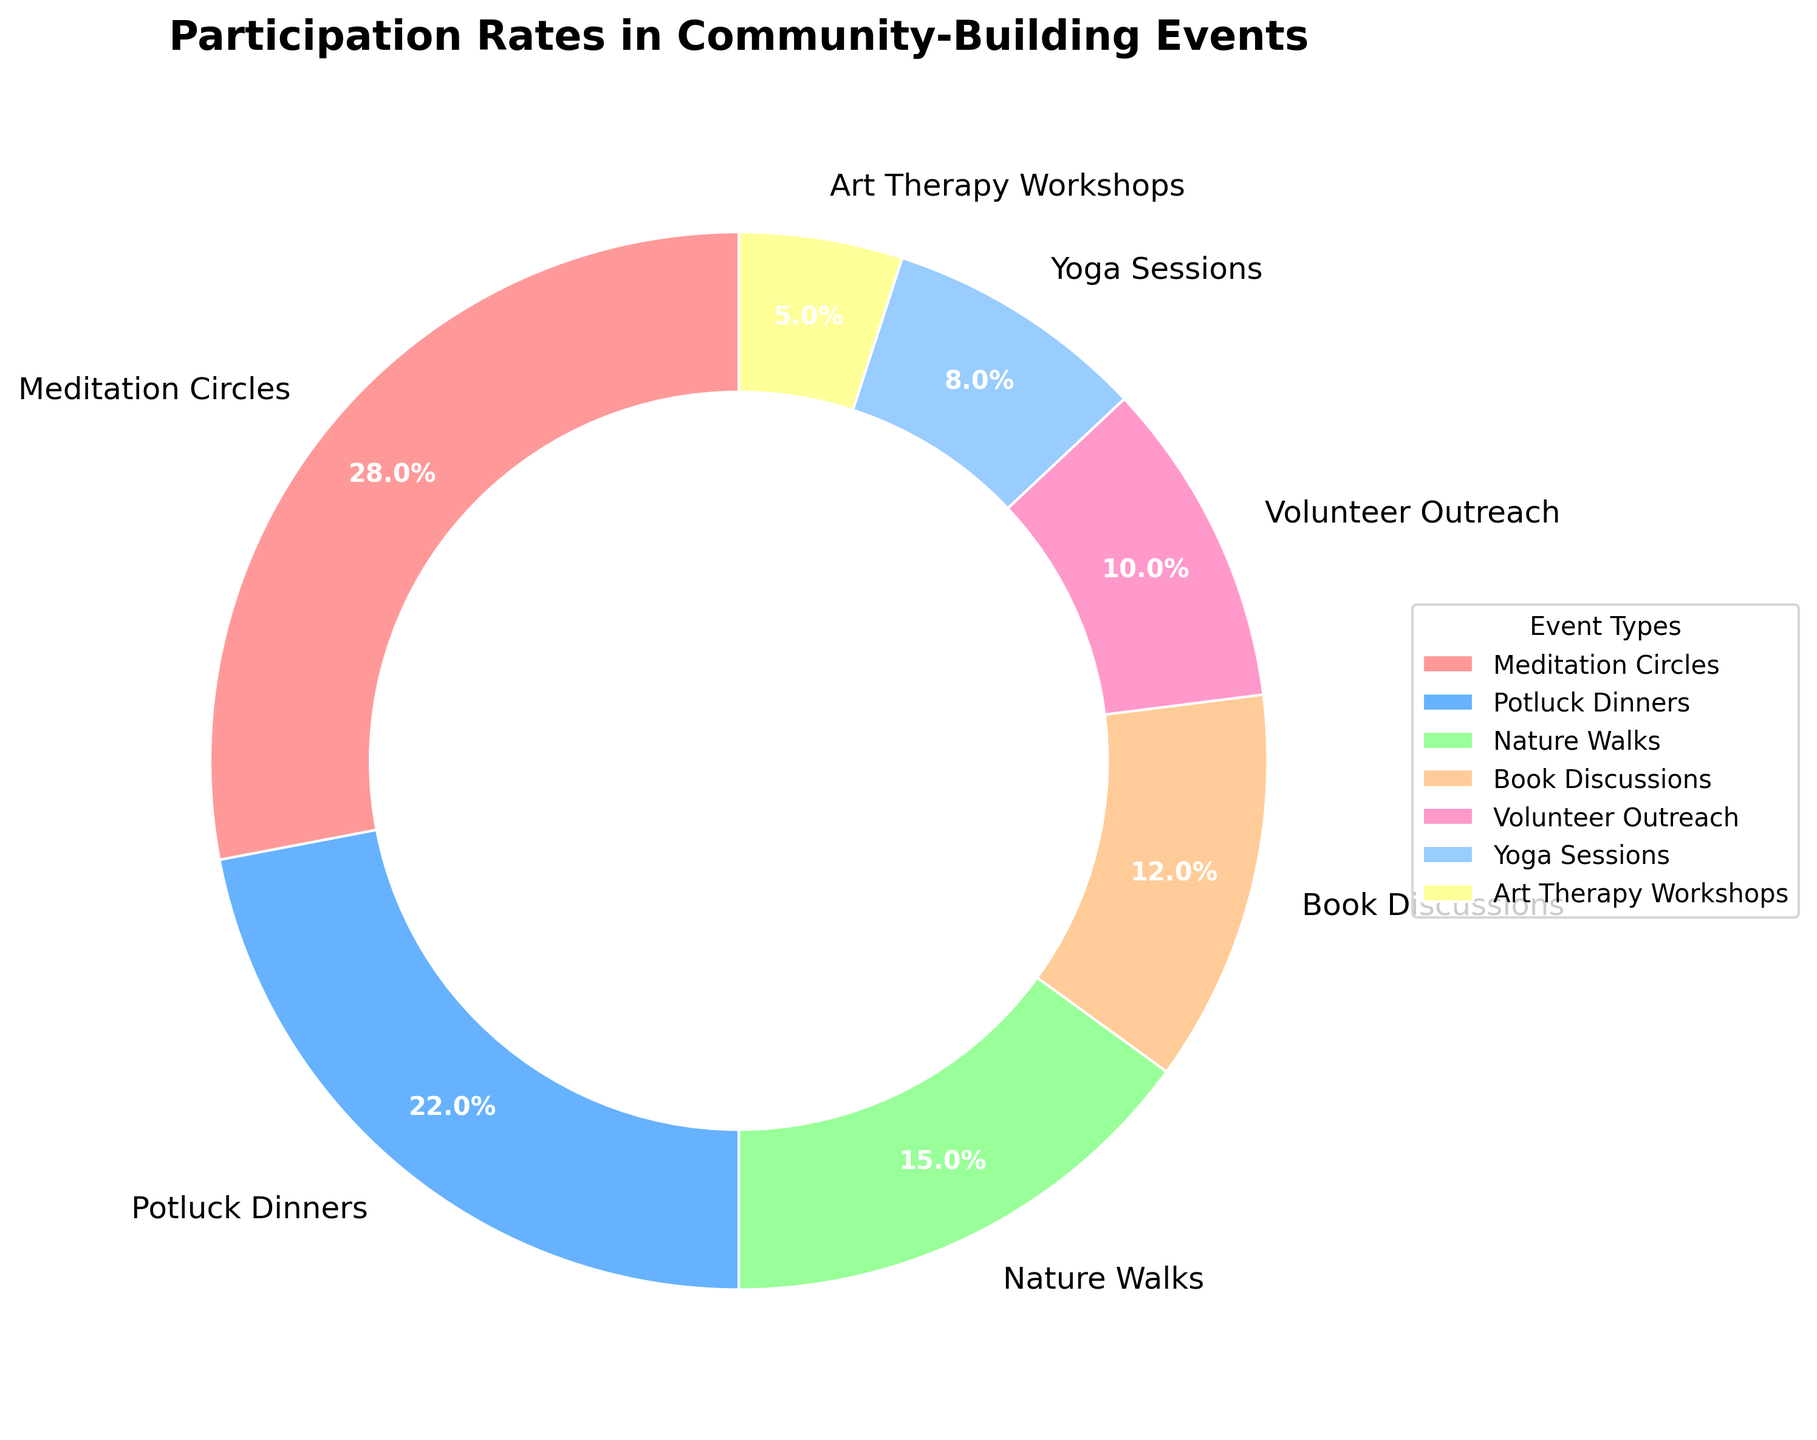What event has the highest participation rate? The sector representing the largest portion of the pie chart is labeled "Meditation Circles" with a percentage of 28%.
Answer: Meditation Circles Which event has the lowest participation rate? The smallest segment of the pie chart is labeled "Art Therapy Workshops" with a percentage of 5%.
Answer: Art Therapy Workshops Which has a higher participation rate, Yoga Sessions or Book Discussions? Comparing the sectors for Yoga Sessions and Book Discussions, Book Discussions have a higher rate at 12%, while Yoga Sessions have 8%.
Answer: Book Discussions What's the combined participation rate for Potluck Dinners and Nature Walks? Adding the percentages for Potluck Dinners (22%) and Nature Walks (15%) gives a combined rate of 22 + 15 = 37%.
Answer: 37% Is the participation rate for Meditation Circles greater than twice that of Art Therapy Workshops? The participation rate for Meditation Circles is 28%. Twice the rate for Art Therapy Workshops (5%) is 2 * 5 = 10%. Since 28% is greater than 10%, the answer is yes.
Answer: Yes How does the participation rate of Volunteer Outreach compare to Yoga Sessions? Volunteer Outreach has a participation rate of 10%, while Yoga Sessions have 8%. Thus, Volunteer Outreach has a higher rate.
Answer: Volunteer Outreach What is the third most popular event based on participation rate? By ordering the events by their participation rates, the third highest percentage is Nature Walks, which has 15%.
Answer: Nature Walks What's the difference in participation rates between the most and least popular events? The most popular event, Meditation Circles, has 28%, and the least popular event, Art Therapy Workshops, has 5%. The difference is 28 - 5 = 23%.
Answer: 23% What proportion of the total participation rate is accounted for by the three least popular events? Summing the rates for Art Therapy Workshops (5%), Yoga Sessions (8%), and Volunteer Outreach (10%) gives 5 + 8 + 10 = 23%.
Answer: 23% Which events have participation rates greater than 10%? The sectors with percentages greater than 10% are Meditation Circles (28%), Potluck Dinners (22%), and Nature Walks (15%).
Answer: Meditation Circles, Potluck Dinners, Nature Walks 